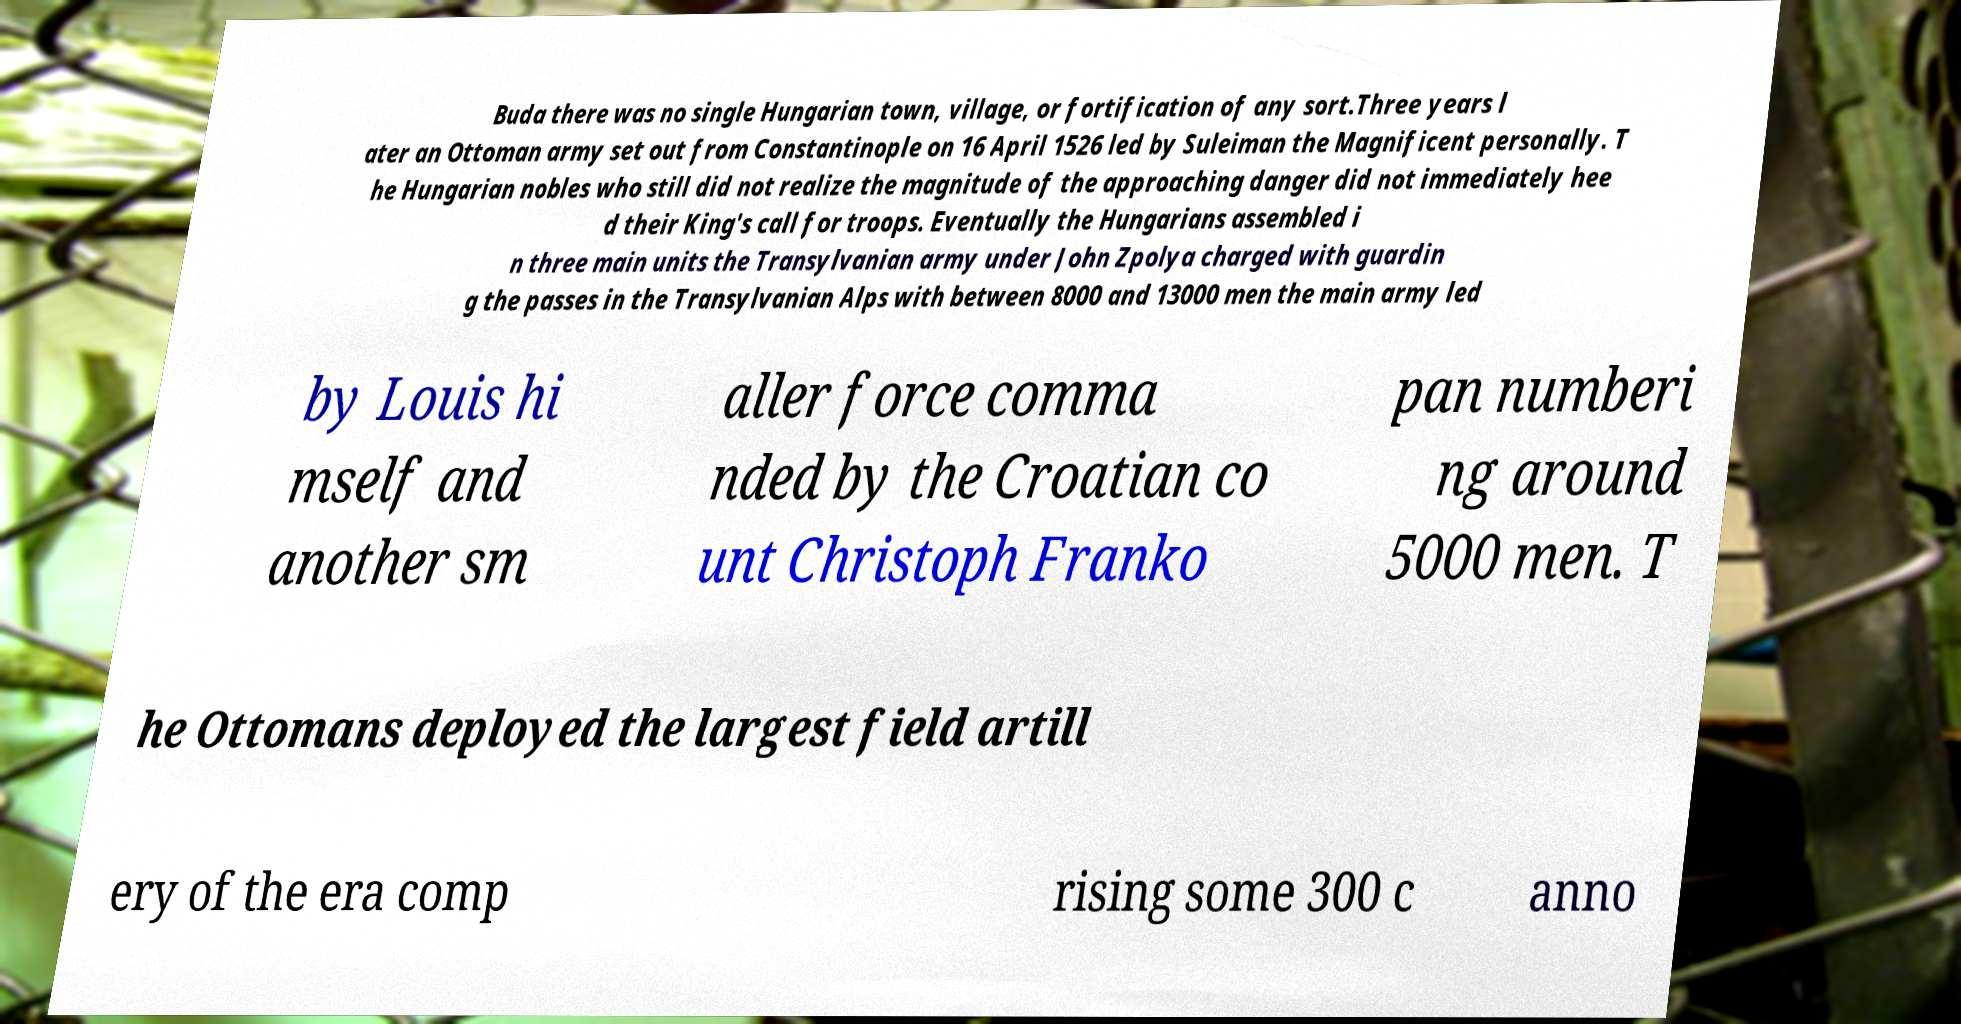Please read and relay the text visible in this image. What does it say? Buda there was no single Hungarian town, village, or fortification of any sort.Three years l ater an Ottoman army set out from Constantinople on 16 April 1526 led by Suleiman the Magnificent personally. T he Hungarian nobles who still did not realize the magnitude of the approaching danger did not immediately hee d their King's call for troops. Eventually the Hungarians assembled i n three main units the Transylvanian army under John Zpolya charged with guardin g the passes in the Transylvanian Alps with between 8000 and 13000 men the main army led by Louis hi mself and another sm aller force comma nded by the Croatian co unt Christoph Franko pan numberi ng around 5000 men. T he Ottomans deployed the largest field artill ery of the era comp rising some 300 c anno 